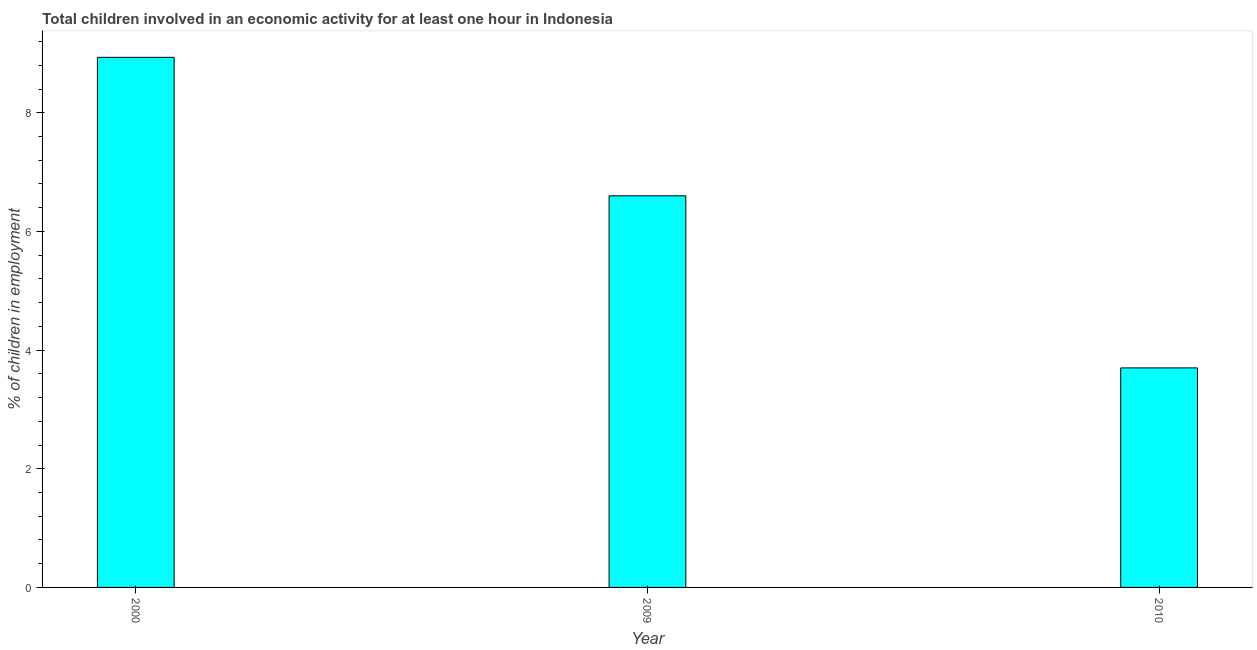Does the graph contain any zero values?
Offer a very short reply. No. What is the title of the graph?
Keep it short and to the point. Total children involved in an economic activity for at least one hour in Indonesia. What is the label or title of the X-axis?
Give a very brief answer. Year. What is the label or title of the Y-axis?
Make the answer very short. % of children in employment. What is the percentage of children in employment in 2000?
Offer a terse response. 8.93. Across all years, what is the maximum percentage of children in employment?
Keep it short and to the point. 8.93. What is the sum of the percentage of children in employment?
Make the answer very short. 19.23. What is the difference between the percentage of children in employment in 2000 and 2009?
Ensure brevity in your answer.  2.33. What is the average percentage of children in employment per year?
Offer a very short reply. 6.41. What is the median percentage of children in employment?
Ensure brevity in your answer.  6.6. In how many years, is the percentage of children in employment greater than 8 %?
Your response must be concise. 1. Do a majority of the years between 2009 and 2010 (inclusive) have percentage of children in employment greater than 6 %?
Your answer should be compact. No. What is the ratio of the percentage of children in employment in 2000 to that in 2010?
Ensure brevity in your answer.  2.42. Is the percentage of children in employment in 2000 less than that in 2010?
Make the answer very short. No. What is the difference between the highest and the second highest percentage of children in employment?
Your answer should be very brief. 2.33. What is the difference between the highest and the lowest percentage of children in employment?
Keep it short and to the point. 5.23. In how many years, is the percentage of children in employment greater than the average percentage of children in employment taken over all years?
Offer a very short reply. 2. How many bars are there?
Your answer should be compact. 3. Are all the bars in the graph horizontal?
Provide a succinct answer. No. How many years are there in the graph?
Offer a very short reply. 3. What is the difference between two consecutive major ticks on the Y-axis?
Offer a very short reply. 2. Are the values on the major ticks of Y-axis written in scientific E-notation?
Offer a very short reply. No. What is the % of children in employment of 2000?
Provide a succinct answer. 8.93. What is the difference between the % of children in employment in 2000 and 2009?
Provide a short and direct response. 2.33. What is the difference between the % of children in employment in 2000 and 2010?
Provide a short and direct response. 5.23. What is the ratio of the % of children in employment in 2000 to that in 2009?
Offer a terse response. 1.35. What is the ratio of the % of children in employment in 2000 to that in 2010?
Provide a succinct answer. 2.42. What is the ratio of the % of children in employment in 2009 to that in 2010?
Ensure brevity in your answer.  1.78. 